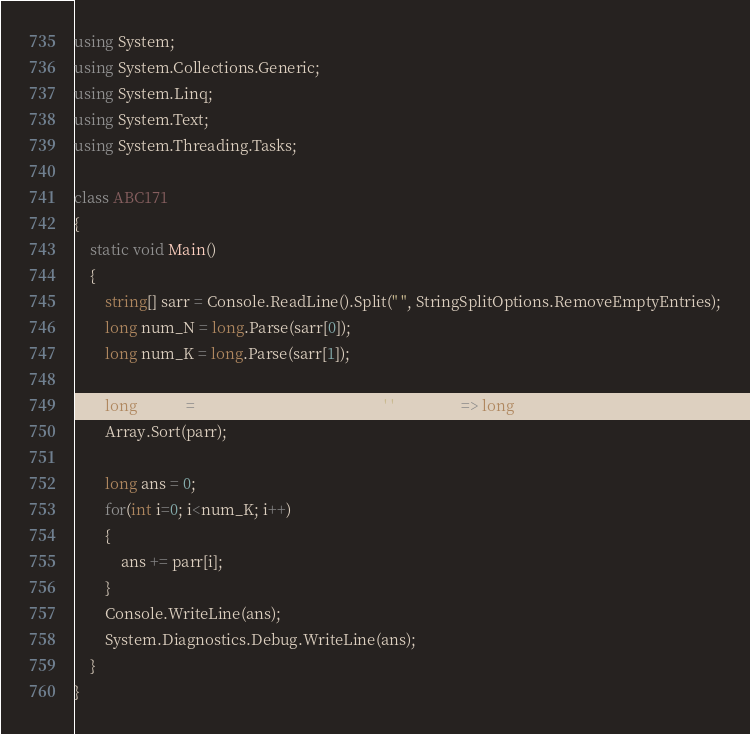<code> <loc_0><loc_0><loc_500><loc_500><_C#_>using System;
using System.Collections.Generic;
using System.Linq;
using System.Text;
using System.Threading.Tasks;

class ABC171
{
    static void Main()
    {
        string[] sarr = Console.ReadLine().Split(" ", StringSplitOptions.RemoveEmptyEntries);
        long num_N = long.Parse(sarr[0]);
        long num_K = long.Parse(sarr[1]);

        long[] parr = Console.ReadLine().Split(' ').Select(i => long.Parse(i)).ToArray();
        Array.Sort(parr);

        long ans = 0;
        for(int i=0; i<num_K; i++)
        {
            ans += parr[i];
        }
        Console.WriteLine(ans);
        System.Diagnostics.Debug.WriteLine(ans);
    }
}</code> 